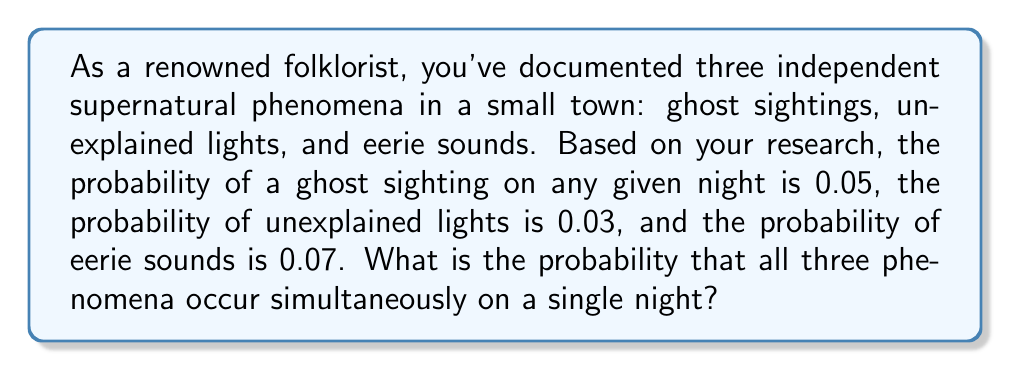Can you solve this math problem? To solve this problem, we need to use the multiplication rule for independent events. Since the three phenomena are independent, we multiply their individual probabilities to find the probability of all three occurring simultaneously.

Let's define our events:
$G$: Ghost sighting
$L$: Unexplained lights
$S$: Eerie sounds

Given probabilities:
$P(G) = 0.05$
$P(L) = 0.03$
$P(S) = 0.07$

The probability of all three events occurring simultaneously is:

$$P(G \cap L \cap S) = P(G) \times P(L) \times P(S)$$

Substituting the values:

$$P(G \cap L \cap S) = 0.05 \times 0.03 \times 0.07$$

Calculating:

$$P(G \cap L \cap S) = 0.0001050$$

This can be expressed as a percentage:

$$0.0001050 \times 100\% = 0.0105\%$$
Answer: The probability of all three supernatural phenomena occurring simultaneously on a single night is 0.0001050 or 0.0105%. 